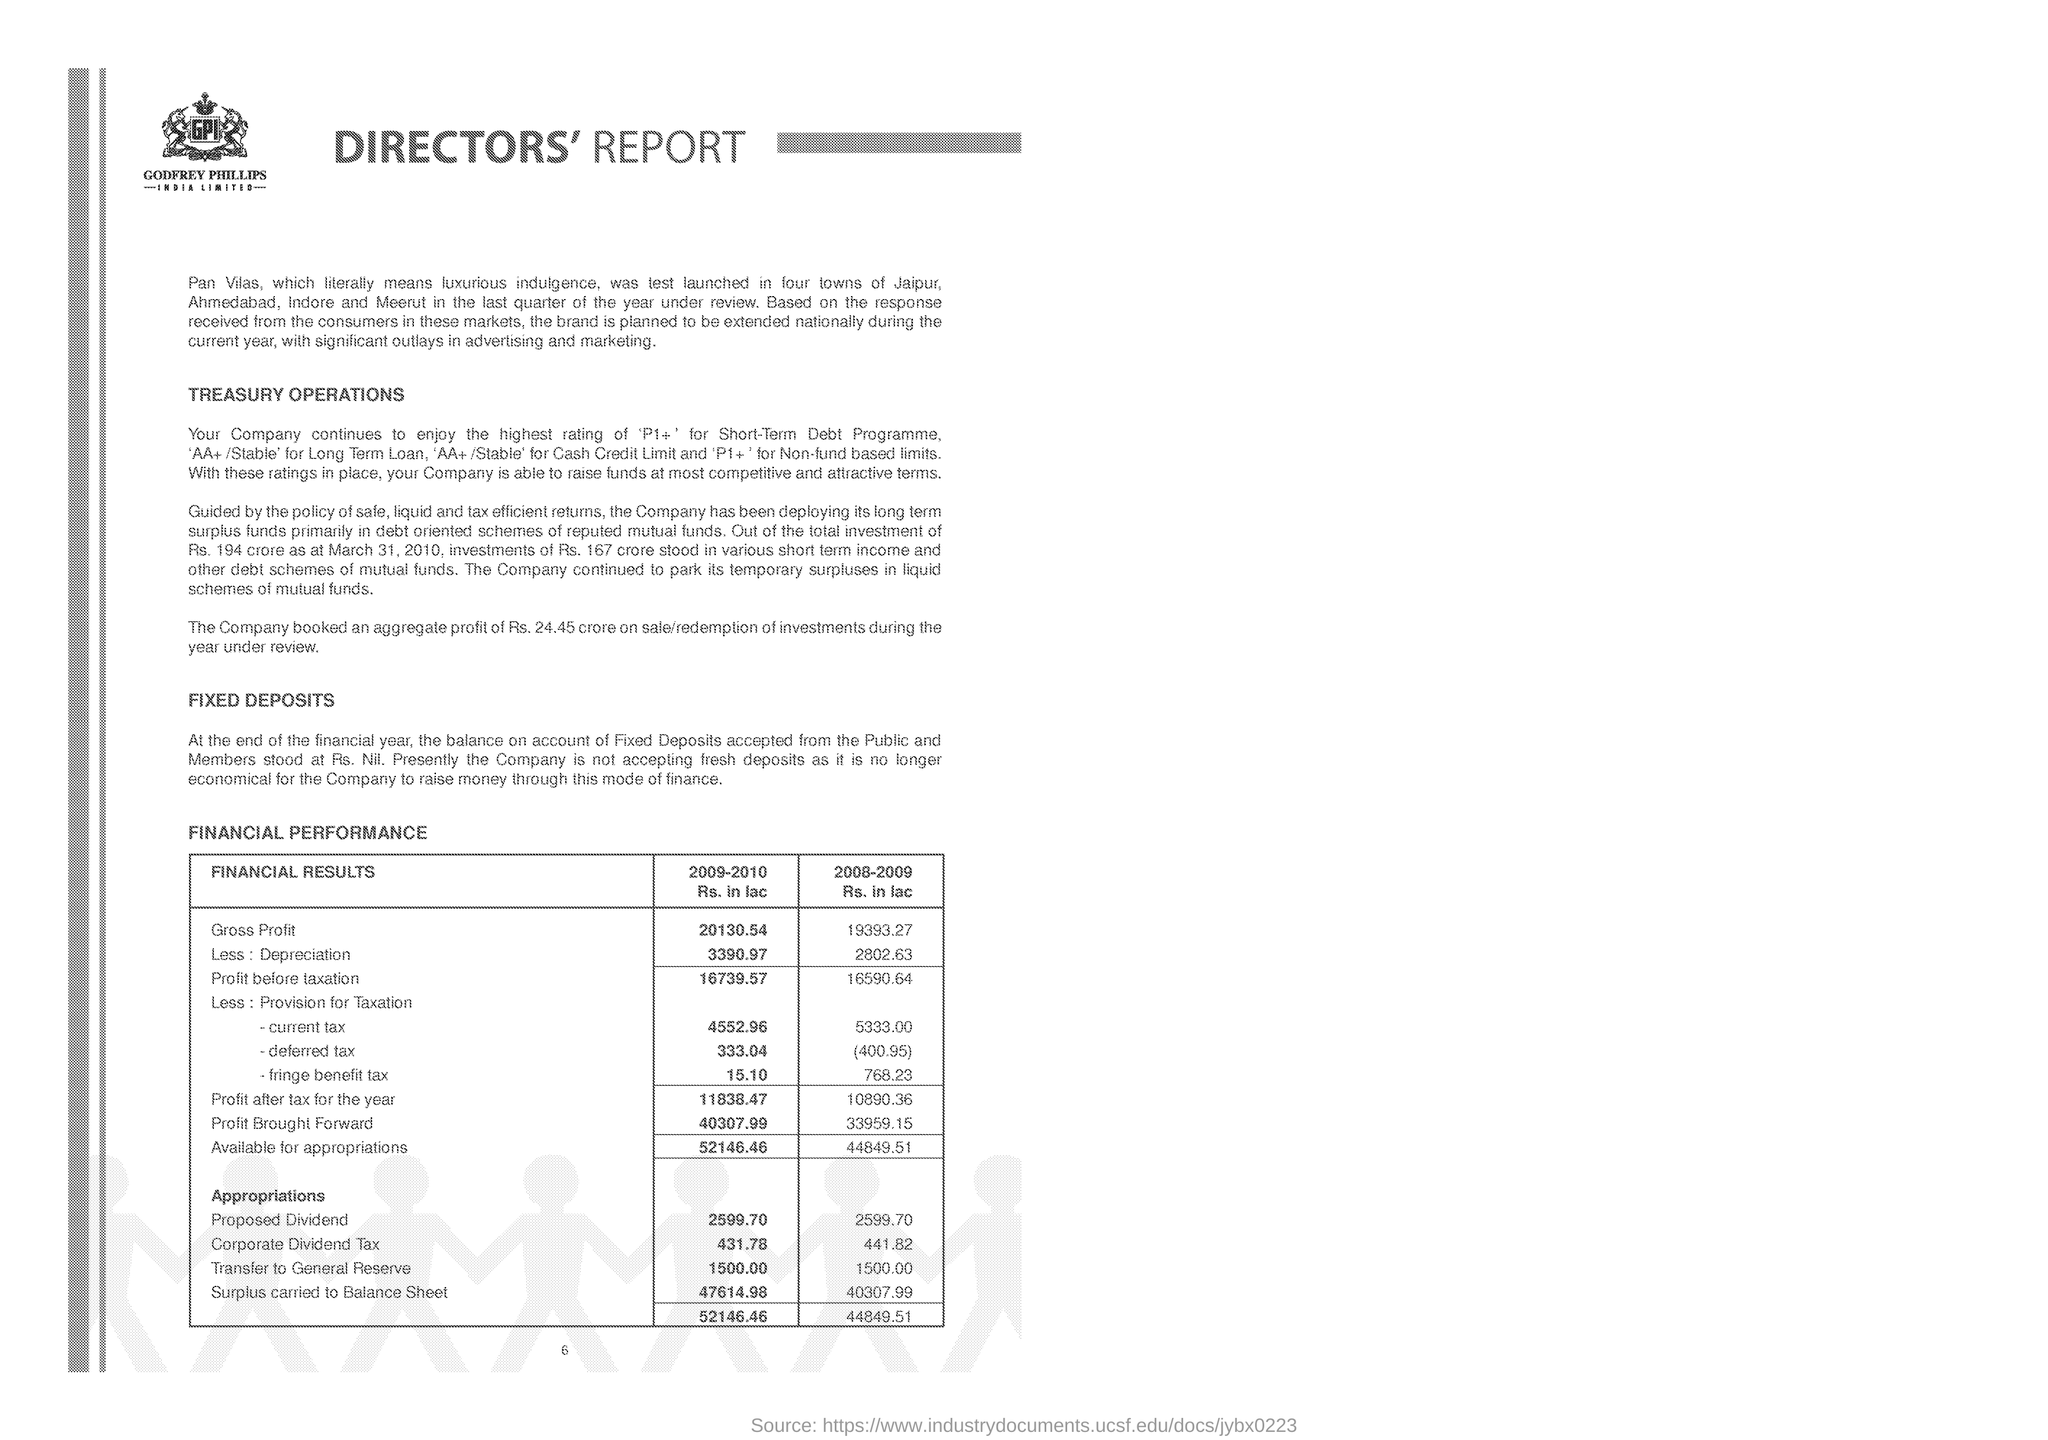What is the Gross Profit (Rs. in lac) in the year 2009-2010?
Your answer should be very brief. 20130.54. What is the Corporate Dividend Tax in the year 2009-2010?
Ensure brevity in your answer.  431.78. What is the Gross Profit (Rs. in lac) in the year 2008-2009?
Ensure brevity in your answer.  19393.27. How much Surplus (Rs. in lac) is carried to Balance Sheet in the year 2009-2010?
Provide a succinct answer. 47614.98. 